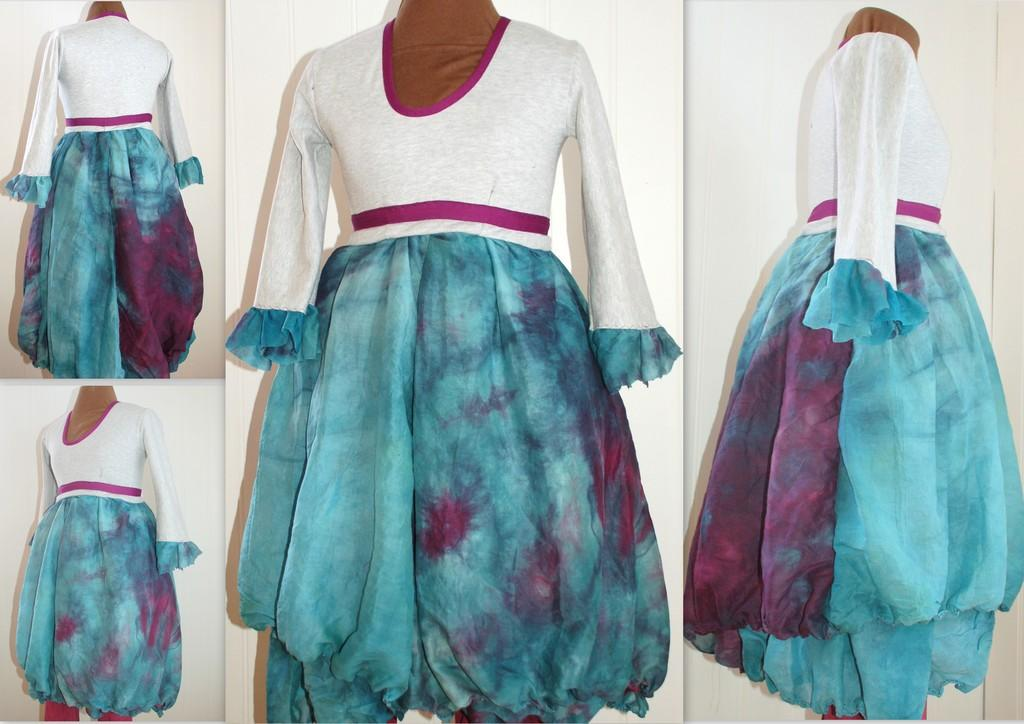What type of artwork is depicted in the image? The image is a collage. What specific item can be found within the collage? There is a dress in the collage. What type of fog can be seen surrounding the dress in the image? There is no fog present in the image; it is a collage featuring a dress. 